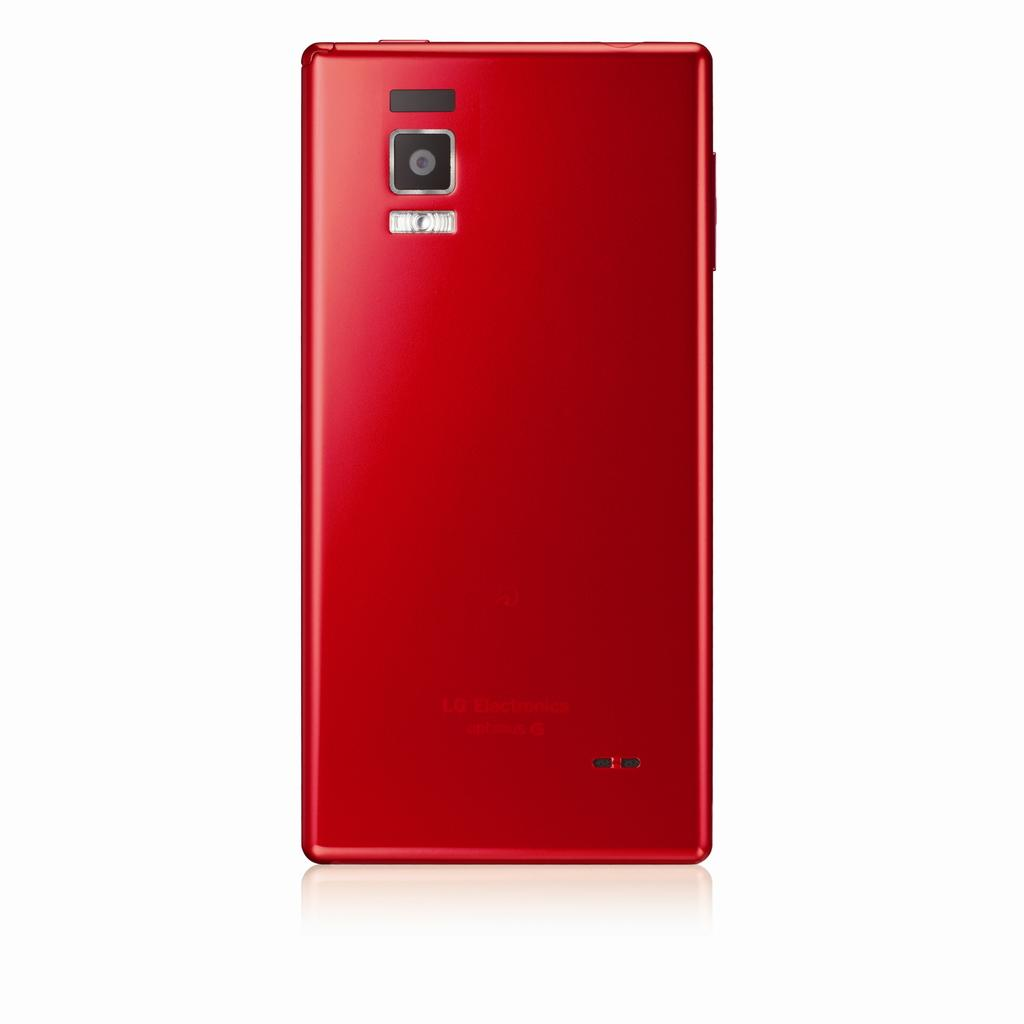<image>
Share a concise interpretation of the image provided. a red phone that says 'LG electronics' on the back of it 